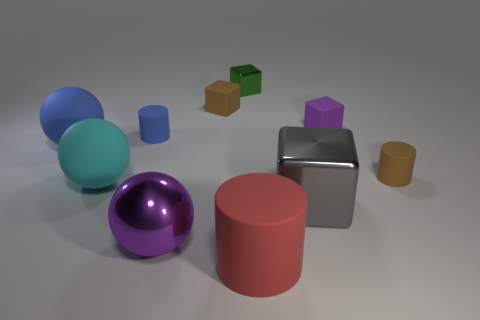The purple shiny ball is what size?
Your answer should be very brief. Large. How many tiny objects are the same color as the shiny ball?
Provide a short and direct response. 1. There is a tiny cylinder behind the tiny brown thing right of the large block; is there a ball behind it?
Ensure brevity in your answer.  No. There is a green object that is the same size as the purple rubber object; what shape is it?
Offer a very short reply. Cube. What number of small things are either cylinders or green cubes?
Your answer should be very brief. 3. There is a big cylinder that is made of the same material as the large blue object; what color is it?
Offer a terse response. Red. Do the brown rubber object to the left of the big red object and the big rubber thing behind the brown cylinder have the same shape?
Make the answer very short. No. How many shiny objects are either big red cylinders or tiny purple blocks?
Offer a terse response. 0. There is a tiny block that is the same color as the metallic sphere; what is its material?
Provide a succinct answer. Rubber. There is a brown thing right of the tiny green shiny cube; what is its material?
Offer a terse response. Rubber. 